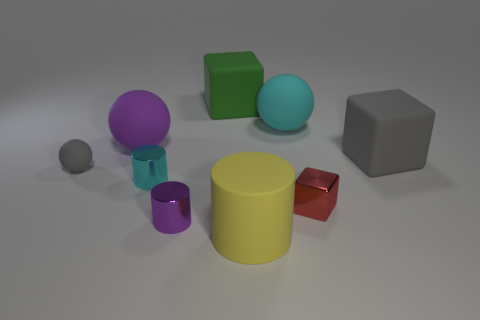What time of day does the lighting in the image suggest? It's difficult to determine the time of day from the image as the lighting appears artificial and neutral, suggesting it could be an indoor setting with controlled lighting conditions. 